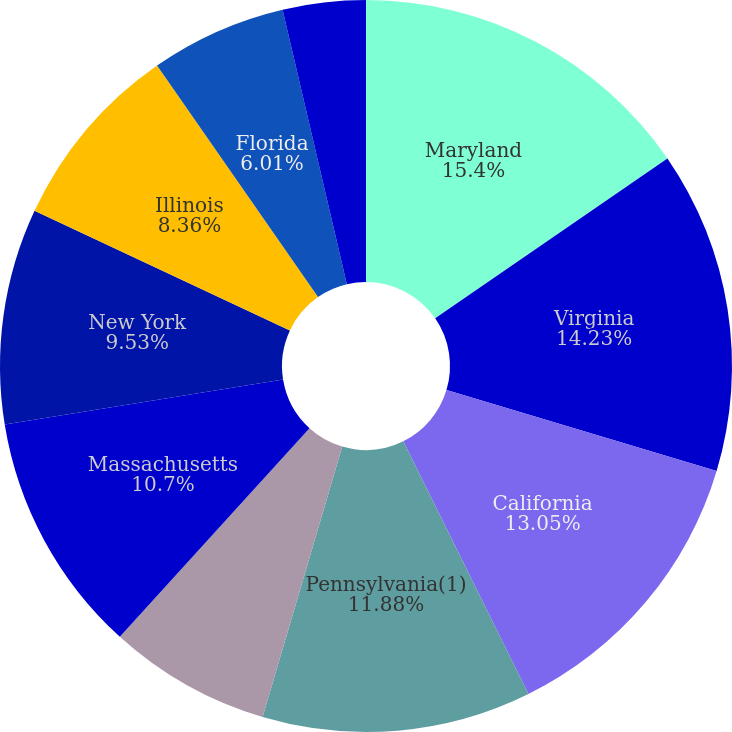Convert chart. <chart><loc_0><loc_0><loc_500><loc_500><pie_chart><fcel>Maryland<fcel>Virginia<fcel>California<fcel>Pennsylvania(1)<fcel>New Jersey<fcel>Massachusetts<fcel>New York<fcel>Illinois<fcel>Florida<fcel>Connecticut(1)<nl><fcel>15.4%<fcel>14.23%<fcel>13.05%<fcel>11.88%<fcel>7.18%<fcel>10.7%<fcel>9.53%<fcel>8.36%<fcel>6.01%<fcel>3.66%<nl></chart> 